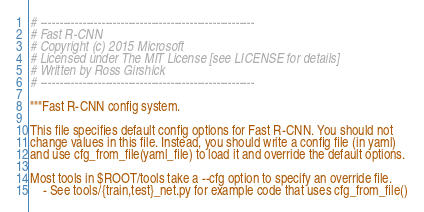Convert code to text. <code><loc_0><loc_0><loc_500><loc_500><_Python_># --------------------------------------------------------
# Fast R-CNN
# Copyright (c) 2015 Microsoft
# Licensed under The MIT License [see LICENSE for details]
# Written by Ross Girshick
# --------------------------------------------------------

"""Fast R-CNN config system.

This file specifies default config options for Fast R-CNN. You should not
change values in this file. Instead, you should write a config file (in yaml)
and use cfg_from_file(yaml_file) to load it and override the default options.

Most tools in $ROOT/tools take a --cfg option to specify an override file.
    - See tools/{train,test}_net.py for example code that uses cfg_from_file()</code> 